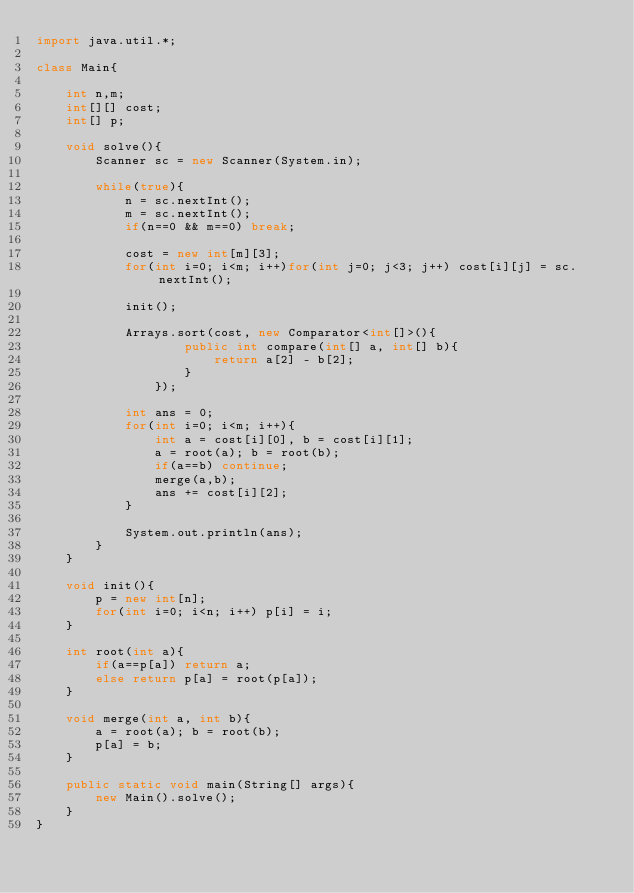Convert code to text. <code><loc_0><loc_0><loc_500><loc_500><_Java_>import java.util.*;

class Main{

    int n,m;
    int[][] cost;
    int[] p;

    void solve(){
        Scanner sc = new Scanner(System.in);

        while(true){
            n = sc.nextInt();
            m = sc.nextInt();
            if(n==0 && m==0) break;

            cost = new int[m][3];
            for(int i=0; i<m; i++)for(int j=0; j<3; j++) cost[i][j] = sc.nextInt();

            init();

            Arrays.sort(cost, new Comparator<int[]>(){
                    public int compare(int[] a, int[] b){
                        return a[2] - b[2];
                    }
                });

            int ans = 0;
            for(int i=0; i<m; i++){
                int a = cost[i][0], b = cost[i][1];
                a = root(a); b = root(b);
                if(a==b) continue;
                merge(a,b);
                ans += cost[i][2];
            }

            System.out.println(ans);
        }
    }

    void init(){
        p = new int[n];
        for(int i=0; i<n; i++) p[i] = i;
    }

    int root(int a){
        if(a==p[a]) return a;
        else return p[a] = root(p[a]);
    }

    void merge(int a, int b){
        a = root(a); b = root(b);
        p[a] = b;
    }

    public static void main(String[] args){
        new Main().solve();
    }
}</code> 